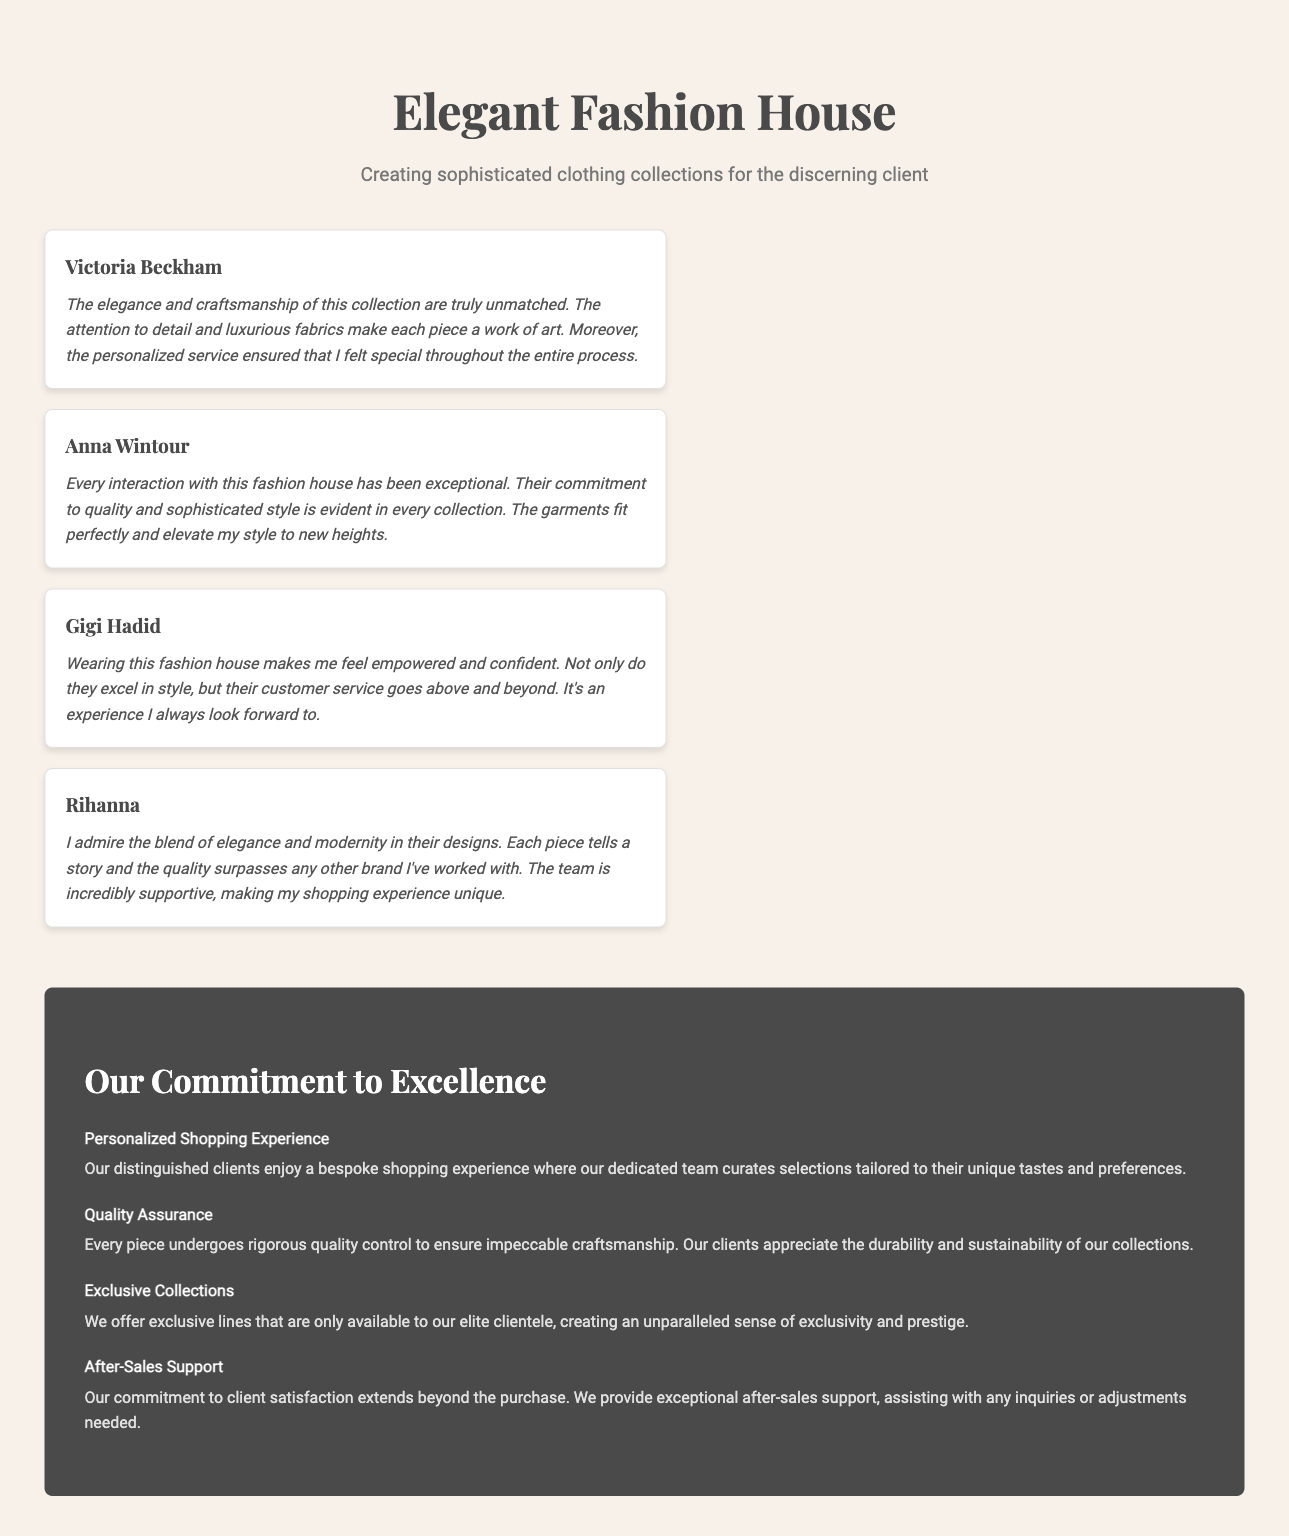What is the name of the first client testimonial? The first client testimonial is attributed to Victoria Beckham.
Answer: Victoria Beckham What is the main theme presented in the testimonials? The testimonials highlight exceptional quality and service provided by the fashion house.
Answer: Quality and service How does Gigi Hadid describe her feelings when wearing the clothing? Gigi Hadid refers to feeling empowered and confident in the clothing.
Answer: Empowered and confident What is one aspect of the personalized shopping experience mentioned? A curated selection tailored to unique tastes and preferences is highlighted.
Answer: Curated selection How many client testimonials are included in the document? There are a total of four client testimonials featured in the document.
Answer: Four 